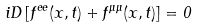Convert formula to latex. <formula><loc_0><loc_0><loc_500><loc_500>i D \left [ f ^ { e e } ( x , t ) + f ^ { \mu \mu } ( x , t ) \right ] = 0 \,</formula> 